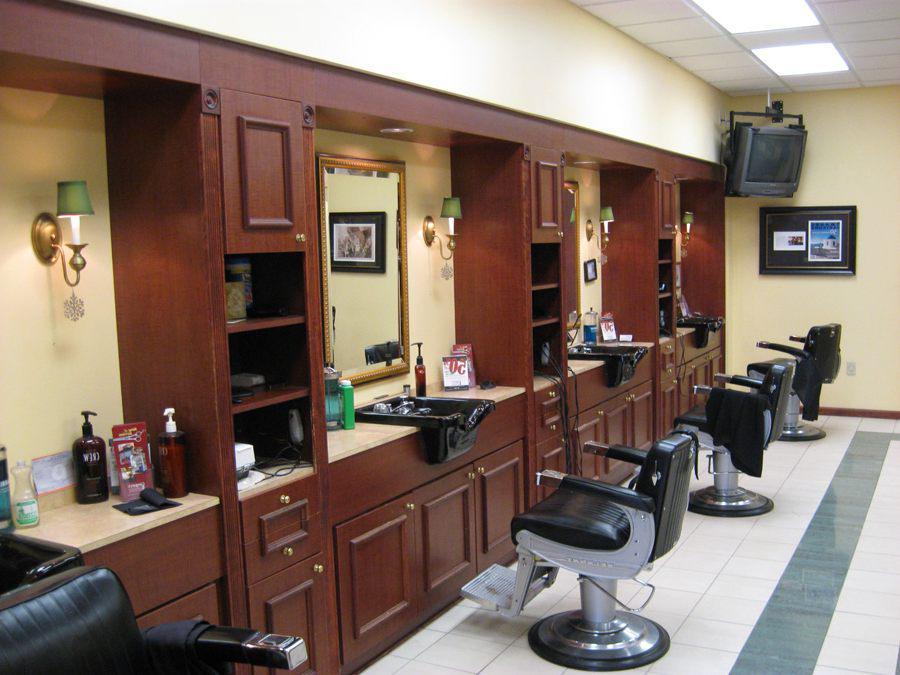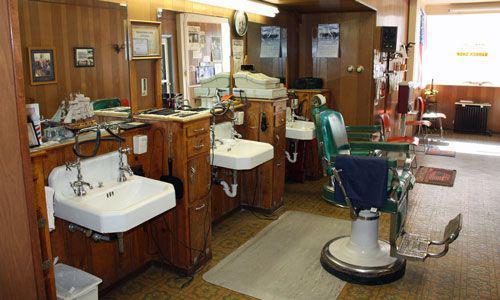The first image is the image on the left, the second image is the image on the right. Analyze the images presented: Is the assertion "In the left image, a row of empty black barber chairs face leftward toward a countertop." valid? Answer yes or no. Yes. The first image is the image on the left, the second image is the image on the right. For the images displayed, is the sentence "In at least one image there are at least two red empty barber chairs." factually correct? Answer yes or no. No. 